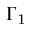Convert formula to latex. <formula><loc_0><loc_0><loc_500><loc_500>\Gamma _ { 1 }</formula> 